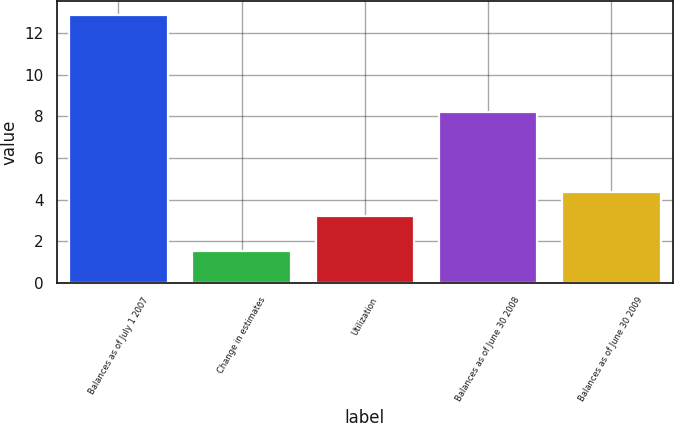Convert chart to OTSL. <chart><loc_0><loc_0><loc_500><loc_500><bar_chart><fcel>Balances as of July 1 2007<fcel>Change in estimates<fcel>Utilization<fcel>Balances as of June 30 2008<fcel>Balances as of June 30 2009<nl><fcel>12.9<fcel>1.5<fcel>3.2<fcel>8.2<fcel>4.34<nl></chart> 